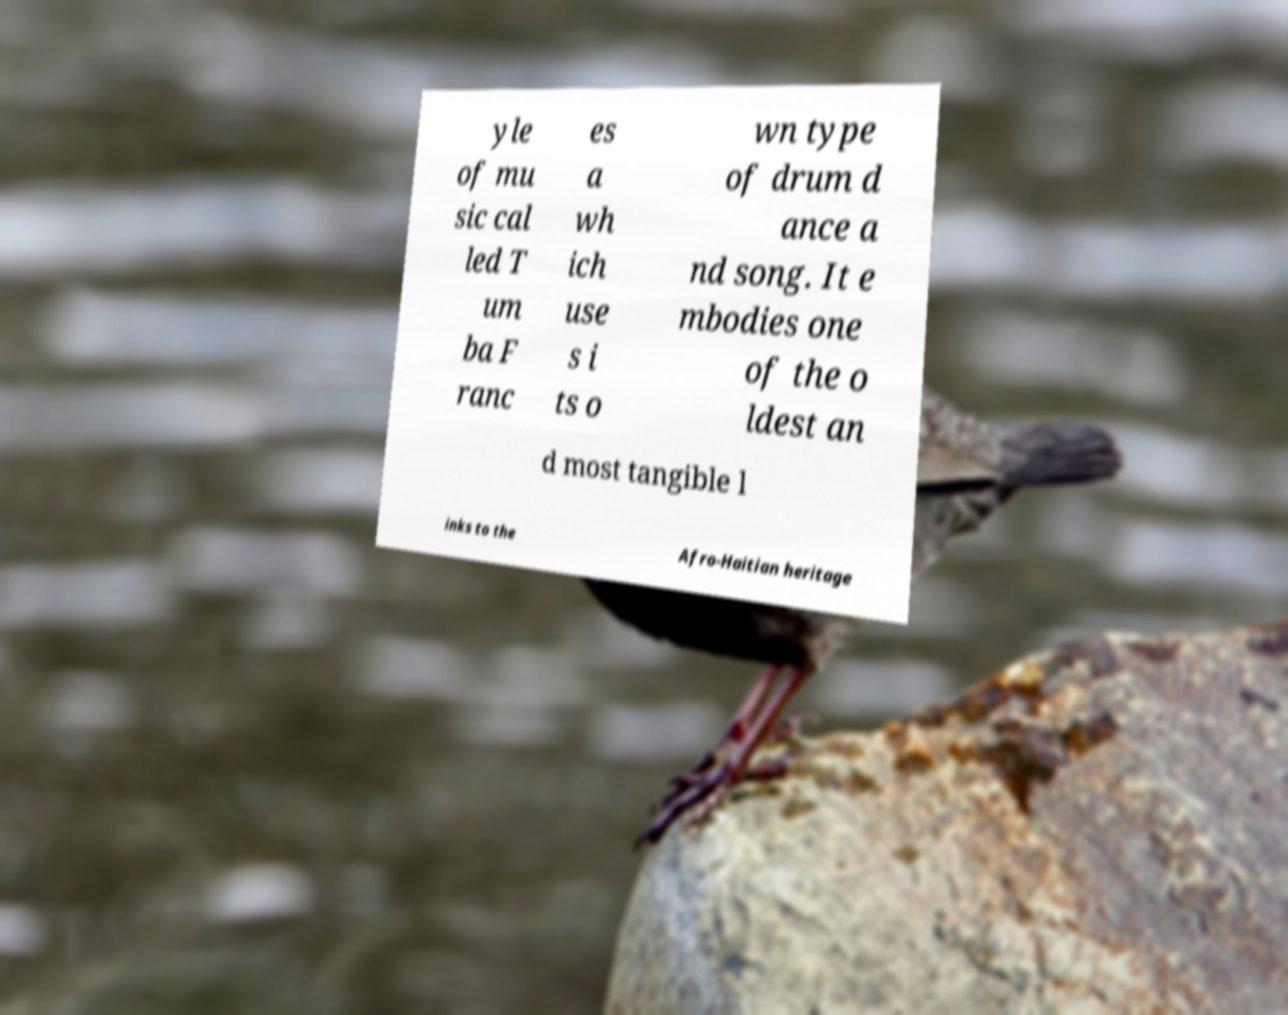For documentation purposes, I need the text within this image transcribed. Could you provide that? yle of mu sic cal led T um ba F ranc es a wh ich use s i ts o wn type of drum d ance a nd song. It e mbodies one of the o ldest an d most tangible l inks to the Afro-Haitian heritage 